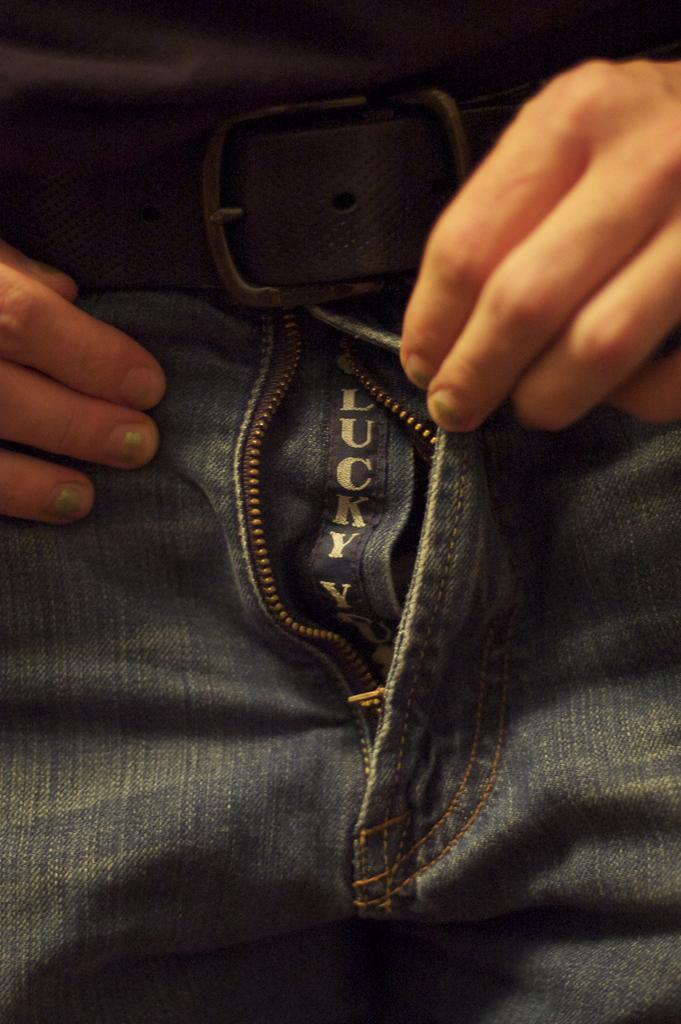Can you describe this image briefly? In this image I can see hands of a person. I can also see a black colour belt, a jeans and in the centre of this image I can see something is written on the jeans. 